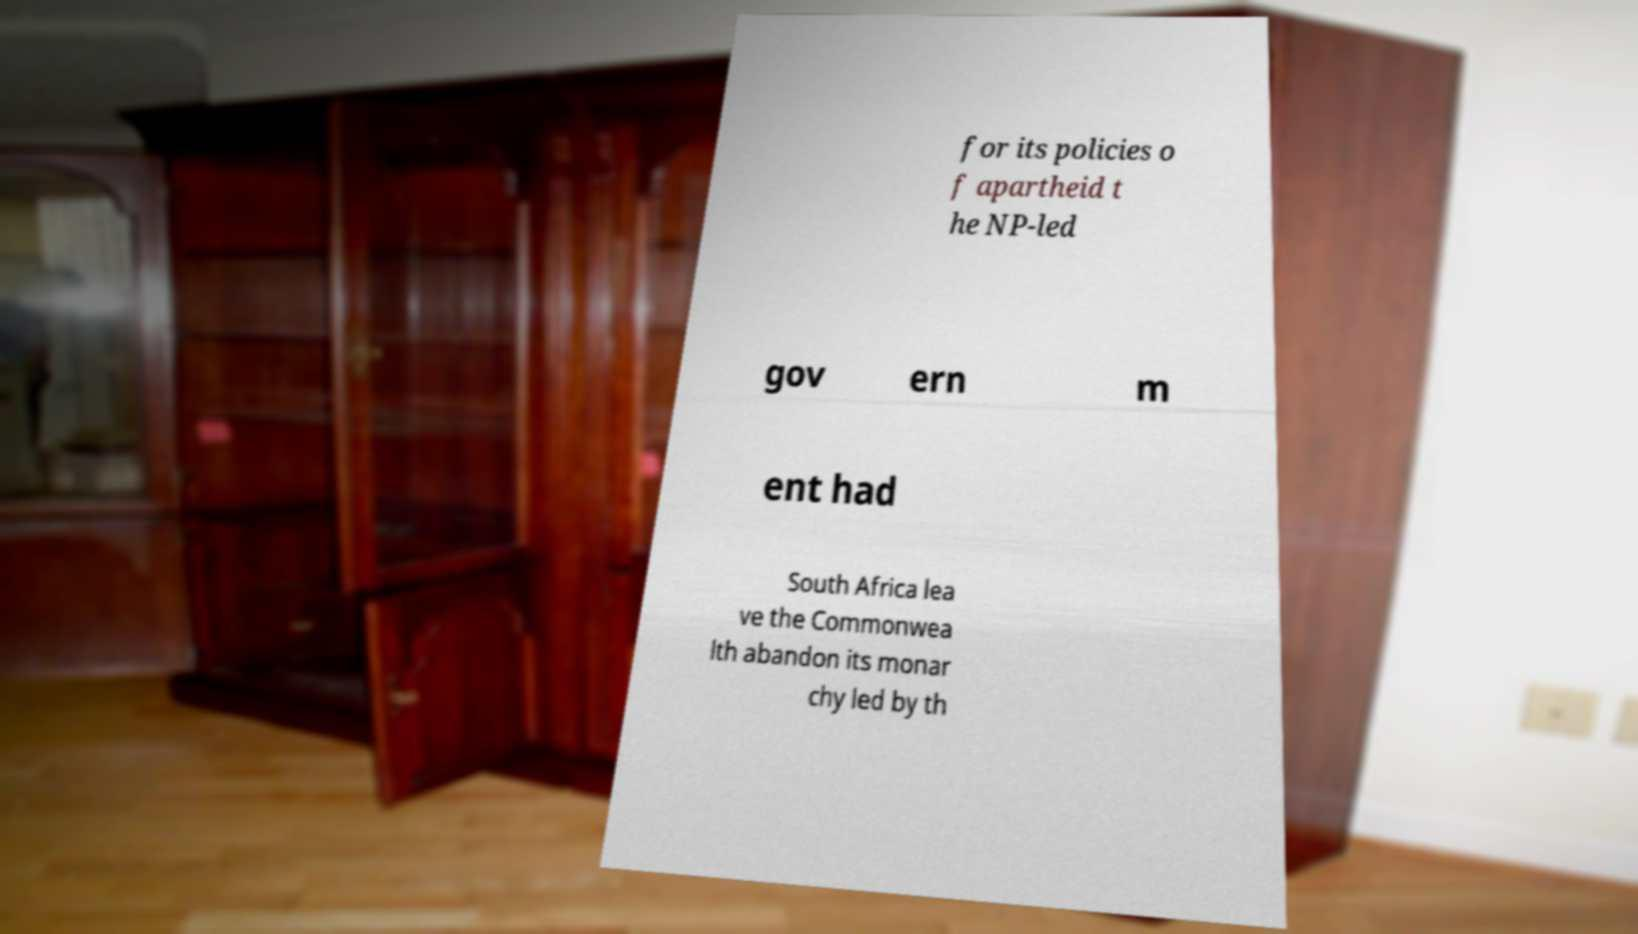What messages or text are displayed in this image? I need them in a readable, typed format. for its policies o f apartheid t he NP-led gov ern m ent had South Africa lea ve the Commonwea lth abandon its monar chy led by th 